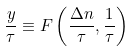<formula> <loc_0><loc_0><loc_500><loc_500>\frac { y } { \tau } \equiv F \left ( \frac { \Delta n } { \tau } , \frac { 1 } { \tau } \right )</formula> 